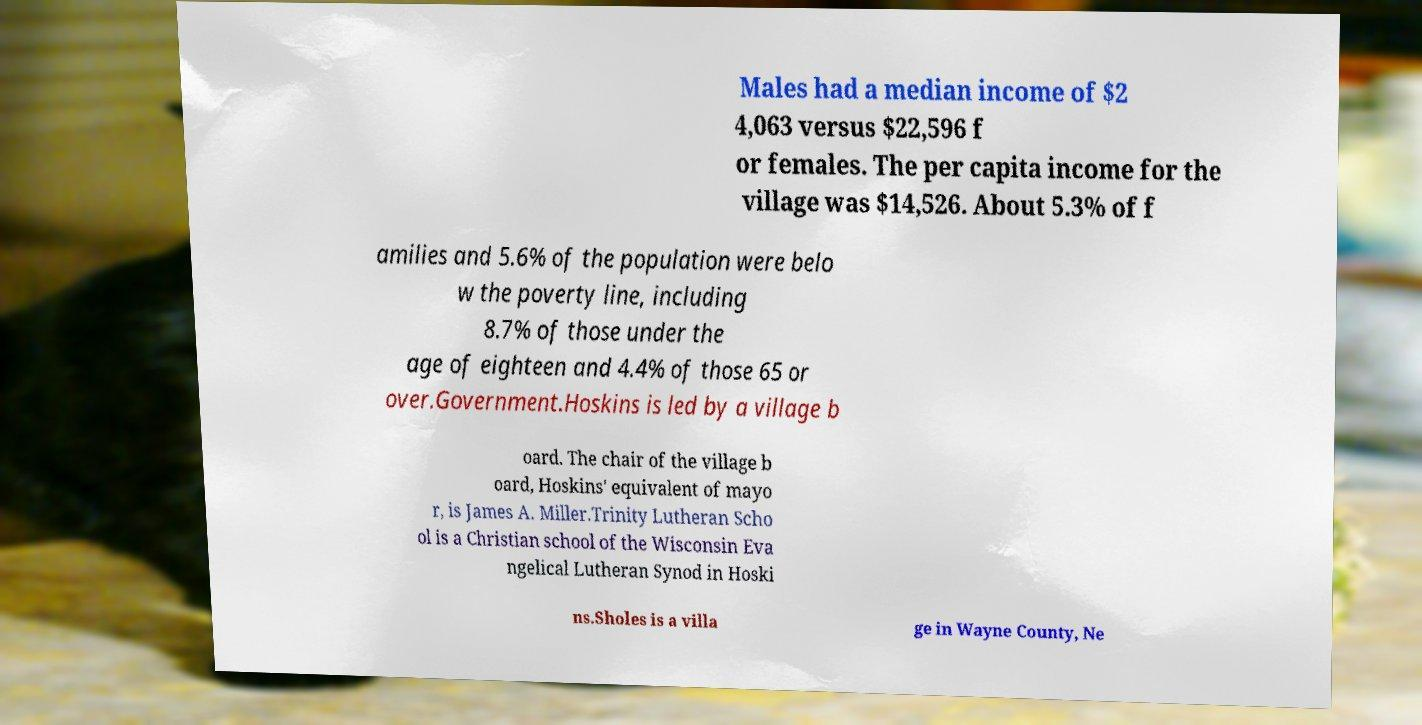Can you read and provide the text displayed in the image?This photo seems to have some interesting text. Can you extract and type it out for me? Males had a median income of $2 4,063 versus $22,596 f or females. The per capita income for the village was $14,526. About 5.3% of f amilies and 5.6% of the population were belo w the poverty line, including 8.7% of those under the age of eighteen and 4.4% of those 65 or over.Government.Hoskins is led by a village b oard. The chair of the village b oard, Hoskins' equivalent of mayo r, is James A. Miller.Trinity Lutheran Scho ol is a Christian school of the Wisconsin Eva ngelical Lutheran Synod in Hoski ns.Sholes is a villa ge in Wayne County, Ne 